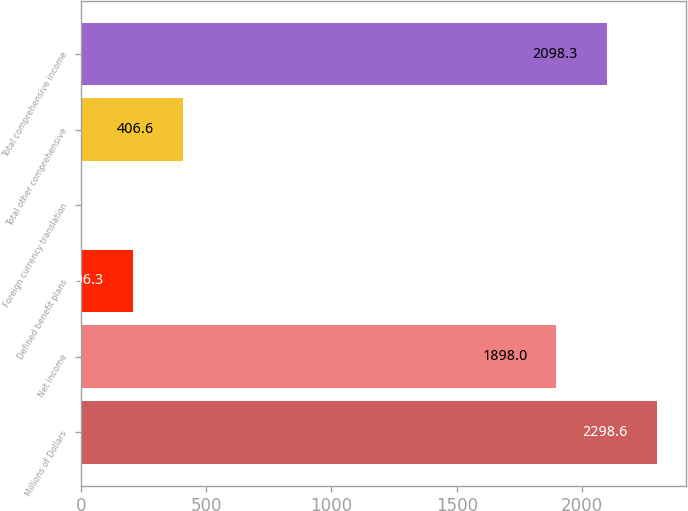<chart> <loc_0><loc_0><loc_500><loc_500><bar_chart><fcel>Millions of Dollars<fcel>Net income<fcel>Defined benefit plans<fcel>Foreign currency translation<fcel>Total other comprehensive<fcel>Total comprehensive income<nl><fcel>2298.6<fcel>1898<fcel>206.3<fcel>6<fcel>406.6<fcel>2098.3<nl></chart> 